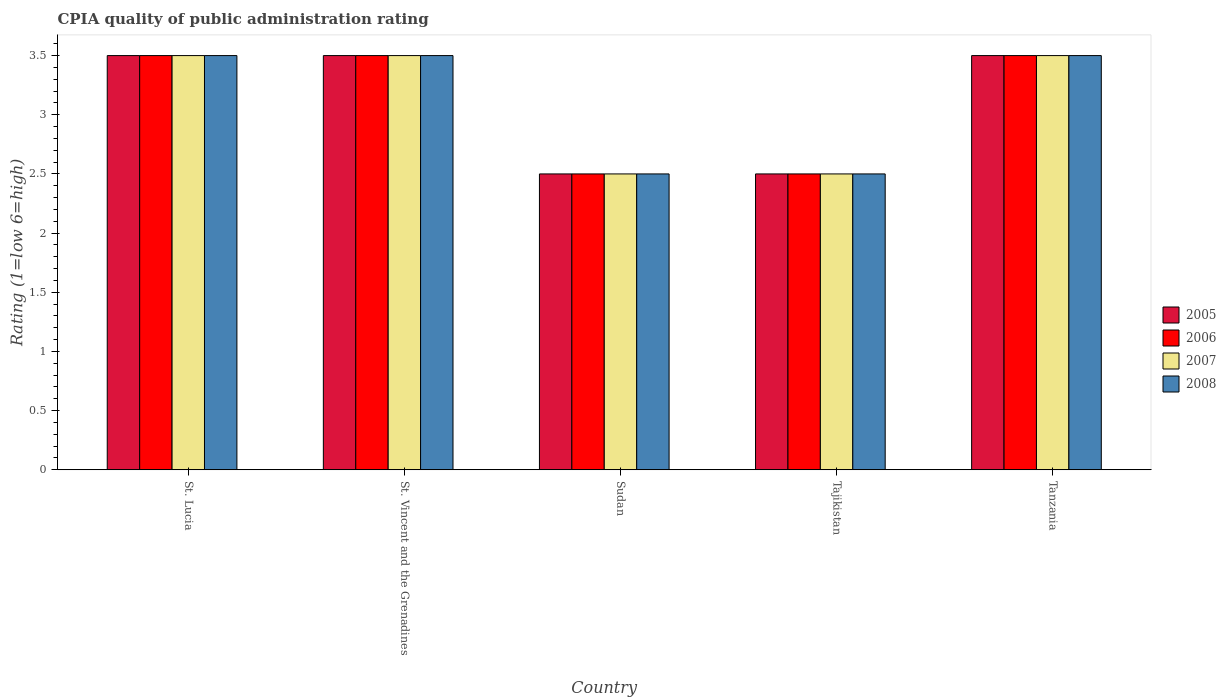How many different coloured bars are there?
Ensure brevity in your answer.  4. How many groups of bars are there?
Make the answer very short. 5. Are the number of bars on each tick of the X-axis equal?
Ensure brevity in your answer.  Yes. How many bars are there on the 5th tick from the right?
Keep it short and to the point. 4. What is the label of the 3rd group of bars from the left?
Give a very brief answer. Sudan. Across all countries, what is the maximum CPIA rating in 2008?
Make the answer very short. 3.5. In which country was the CPIA rating in 2006 maximum?
Provide a succinct answer. St. Lucia. In which country was the CPIA rating in 2008 minimum?
Your response must be concise. Sudan. What is the average CPIA rating in 2005 per country?
Offer a very short reply. 3.1. What is the difference between the CPIA rating of/in 2006 and CPIA rating of/in 2005 in St. Vincent and the Grenadines?
Keep it short and to the point. 0. In how many countries, is the CPIA rating in 2006 greater than 2.2?
Your answer should be compact. 5. Is the difference between the CPIA rating in 2006 in St. Vincent and the Grenadines and Sudan greater than the difference between the CPIA rating in 2005 in St. Vincent and the Grenadines and Sudan?
Make the answer very short. No. In how many countries, is the CPIA rating in 2005 greater than the average CPIA rating in 2005 taken over all countries?
Offer a terse response. 3. Is the sum of the CPIA rating in 2005 in St. Vincent and the Grenadines and Tanzania greater than the maximum CPIA rating in 2006 across all countries?
Your response must be concise. Yes. Is it the case that in every country, the sum of the CPIA rating in 2007 and CPIA rating in 2006 is greater than the sum of CPIA rating in 2008 and CPIA rating in 2005?
Provide a short and direct response. No. What does the 1st bar from the right in Tajikistan represents?
Offer a very short reply. 2008. Are the values on the major ticks of Y-axis written in scientific E-notation?
Ensure brevity in your answer.  No. Does the graph contain grids?
Give a very brief answer. No. Where does the legend appear in the graph?
Ensure brevity in your answer.  Center right. How many legend labels are there?
Your response must be concise. 4. How are the legend labels stacked?
Ensure brevity in your answer.  Vertical. What is the title of the graph?
Ensure brevity in your answer.  CPIA quality of public administration rating. Does "1968" appear as one of the legend labels in the graph?
Your answer should be very brief. No. What is the label or title of the X-axis?
Offer a terse response. Country. What is the Rating (1=low 6=high) of 2005 in St. Lucia?
Your response must be concise. 3.5. What is the Rating (1=low 6=high) in 2007 in St. Lucia?
Give a very brief answer. 3.5. What is the Rating (1=low 6=high) of 2007 in St. Vincent and the Grenadines?
Your answer should be very brief. 3.5. What is the Rating (1=low 6=high) of 2008 in St. Vincent and the Grenadines?
Provide a short and direct response. 3.5. What is the Rating (1=low 6=high) of 2005 in Sudan?
Keep it short and to the point. 2.5. What is the Rating (1=low 6=high) in 2007 in Sudan?
Your answer should be very brief. 2.5. What is the Rating (1=low 6=high) of 2005 in Tajikistan?
Your answer should be compact. 2.5. What is the Rating (1=low 6=high) of 2008 in Tajikistan?
Make the answer very short. 2.5. What is the Rating (1=low 6=high) of 2006 in Tanzania?
Ensure brevity in your answer.  3.5. Across all countries, what is the maximum Rating (1=low 6=high) of 2006?
Provide a short and direct response. 3.5. Across all countries, what is the minimum Rating (1=low 6=high) of 2005?
Keep it short and to the point. 2.5. Across all countries, what is the minimum Rating (1=low 6=high) of 2007?
Provide a short and direct response. 2.5. Across all countries, what is the minimum Rating (1=low 6=high) of 2008?
Make the answer very short. 2.5. What is the total Rating (1=low 6=high) in 2006 in the graph?
Give a very brief answer. 15.5. What is the difference between the Rating (1=low 6=high) of 2005 in St. Lucia and that in St. Vincent and the Grenadines?
Give a very brief answer. 0. What is the difference between the Rating (1=low 6=high) in 2006 in St. Lucia and that in St. Vincent and the Grenadines?
Offer a terse response. 0. What is the difference between the Rating (1=low 6=high) of 2006 in St. Lucia and that in Sudan?
Keep it short and to the point. 1. What is the difference between the Rating (1=low 6=high) of 2007 in St. Lucia and that in Sudan?
Offer a very short reply. 1. What is the difference between the Rating (1=low 6=high) of 2008 in St. Lucia and that in Sudan?
Your response must be concise. 1. What is the difference between the Rating (1=low 6=high) in 2006 in St. Lucia and that in Tajikistan?
Offer a very short reply. 1. What is the difference between the Rating (1=low 6=high) in 2008 in St. Lucia and that in Tajikistan?
Provide a succinct answer. 1. What is the difference between the Rating (1=low 6=high) of 2005 in St. Lucia and that in Tanzania?
Provide a succinct answer. 0. What is the difference between the Rating (1=low 6=high) of 2006 in St. Lucia and that in Tanzania?
Provide a short and direct response. 0. What is the difference between the Rating (1=low 6=high) of 2007 in St. Lucia and that in Tanzania?
Offer a very short reply. 0. What is the difference between the Rating (1=low 6=high) in 2005 in St. Vincent and the Grenadines and that in Sudan?
Give a very brief answer. 1. What is the difference between the Rating (1=low 6=high) of 2006 in St. Vincent and the Grenadines and that in Sudan?
Give a very brief answer. 1. What is the difference between the Rating (1=low 6=high) of 2007 in St. Vincent and the Grenadines and that in Sudan?
Offer a very short reply. 1. What is the difference between the Rating (1=low 6=high) of 2006 in St. Vincent and the Grenadines and that in Tajikistan?
Your answer should be compact. 1. What is the difference between the Rating (1=low 6=high) of 2007 in St. Vincent and the Grenadines and that in Tajikistan?
Your response must be concise. 1. What is the difference between the Rating (1=low 6=high) in 2008 in St. Vincent and the Grenadines and that in Tajikistan?
Your answer should be compact. 1. What is the difference between the Rating (1=low 6=high) of 2005 in St. Vincent and the Grenadines and that in Tanzania?
Your answer should be compact. 0. What is the difference between the Rating (1=low 6=high) in 2007 in St. Vincent and the Grenadines and that in Tanzania?
Your answer should be very brief. 0. What is the difference between the Rating (1=low 6=high) in 2005 in Sudan and that in Tajikistan?
Your response must be concise. 0. What is the difference between the Rating (1=low 6=high) in 2005 in Sudan and that in Tanzania?
Your response must be concise. -1. What is the difference between the Rating (1=low 6=high) in 2007 in Sudan and that in Tanzania?
Your answer should be very brief. -1. What is the difference between the Rating (1=low 6=high) of 2008 in Sudan and that in Tanzania?
Provide a succinct answer. -1. What is the difference between the Rating (1=low 6=high) in 2006 in Tajikistan and that in Tanzania?
Make the answer very short. -1. What is the difference between the Rating (1=low 6=high) in 2007 in Tajikistan and that in Tanzania?
Make the answer very short. -1. What is the difference between the Rating (1=low 6=high) of 2008 in Tajikistan and that in Tanzania?
Make the answer very short. -1. What is the difference between the Rating (1=low 6=high) in 2005 in St. Lucia and the Rating (1=low 6=high) in 2006 in St. Vincent and the Grenadines?
Give a very brief answer. 0. What is the difference between the Rating (1=low 6=high) of 2005 in St. Lucia and the Rating (1=low 6=high) of 2008 in St. Vincent and the Grenadines?
Give a very brief answer. 0. What is the difference between the Rating (1=low 6=high) in 2006 in St. Lucia and the Rating (1=low 6=high) in 2008 in St. Vincent and the Grenadines?
Your answer should be compact. 0. What is the difference between the Rating (1=low 6=high) in 2005 in St. Lucia and the Rating (1=low 6=high) in 2006 in Sudan?
Provide a short and direct response. 1. What is the difference between the Rating (1=low 6=high) of 2005 in St. Lucia and the Rating (1=low 6=high) of 2007 in Sudan?
Ensure brevity in your answer.  1. What is the difference between the Rating (1=low 6=high) in 2005 in St. Lucia and the Rating (1=low 6=high) in 2008 in Sudan?
Your response must be concise. 1. What is the difference between the Rating (1=low 6=high) of 2006 in St. Lucia and the Rating (1=low 6=high) of 2007 in Sudan?
Provide a succinct answer. 1. What is the difference between the Rating (1=low 6=high) of 2006 in St. Lucia and the Rating (1=low 6=high) of 2008 in Sudan?
Offer a very short reply. 1. What is the difference between the Rating (1=low 6=high) of 2007 in St. Lucia and the Rating (1=low 6=high) of 2008 in Sudan?
Make the answer very short. 1. What is the difference between the Rating (1=low 6=high) of 2005 in St. Lucia and the Rating (1=low 6=high) of 2006 in Tajikistan?
Ensure brevity in your answer.  1. What is the difference between the Rating (1=low 6=high) in 2005 in St. Lucia and the Rating (1=low 6=high) in 2007 in Tajikistan?
Offer a very short reply. 1. What is the difference between the Rating (1=low 6=high) of 2006 in St. Lucia and the Rating (1=low 6=high) of 2007 in Tajikistan?
Provide a short and direct response. 1. What is the difference between the Rating (1=low 6=high) in 2006 in St. Lucia and the Rating (1=low 6=high) in 2008 in Tajikistan?
Give a very brief answer. 1. What is the difference between the Rating (1=low 6=high) in 2005 in St. Lucia and the Rating (1=low 6=high) in 2007 in Tanzania?
Your response must be concise. 0. What is the difference between the Rating (1=low 6=high) in 2006 in St. Lucia and the Rating (1=low 6=high) in 2007 in Tanzania?
Give a very brief answer. 0. What is the difference between the Rating (1=low 6=high) of 2005 in St. Vincent and the Grenadines and the Rating (1=low 6=high) of 2007 in Sudan?
Keep it short and to the point. 1. What is the difference between the Rating (1=low 6=high) in 2006 in St. Vincent and the Grenadines and the Rating (1=low 6=high) in 2008 in Sudan?
Provide a short and direct response. 1. What is the difference between the Rating (1=low 6=high) in 2005 in St. Vincent and the Grenadines and the Rating (1=low 6=high) in 2007 in Tajikistan?
Ensure brevity in your answer.  1. What is the difference between the Rating (1=low 6=high) of 2006 in St. Vincent and the Grenadines and the Rating (1=low 6=high) of 2007 in Tajikistan?
Ensure brevity in your answer.  1. What is the difference between the Rating (1=low 6=high) of 2006 in St. Vincent and the Grenadines and the Rating (1=low 6=high) of 2008 in Tajikistan?
Ensure brevity in your answer.  1. What is the difference between the Rating (1=low 6=high) of 2007 in St. Vincent and the Grenadines and the Rating (1=low 6=high) of 2008 in Tajikistan?
Keep it short and to the point. 1. What is the difference between the Rating (1=low 6=high) in 2005 in St. Vincent and the Grenadines and the Rating (1=low 6=high) in 2006 in Tanzania?
Offer a very short reply. 0. What is the difference between the Rating (1=low 6=high) in 2005 in St. Vincent and the Grenadines and the Rating (1=low 6=high) in 2008 in Tanzania?
Keep it short and to the point. 0. What is the difference between the Rating (1=low 6=high) of 2006 in St. Vincent and the Grenadines and the Rating (1=low 6=high) of 2007 in Tanzania?
Your answer should be very brief. 0. What is the difference between the Rating (1=low 6=high) in 2005 in Sudan and the Rating (1=low 6=high) in 2006 in Tajikistan?
Keep it short and to the point. 0. What is the difference between the Rating (1=low 6=high) in 2005 in Sudan and the Rating (1=low 6=high) in 2008 in Tajikistan?
Provide a succinct answer. 0. What is the difference between the Rating (1=low 6=high) in 2006 in Sudan and the Rating (1=low 6=high) in 2007 in Tajikistan?
Your answer should be compact. 0. What is the difference between the Rating (1=low 6=high) of 2005 in Sudan and the Rating (1=low 6=high) of 2007 in Tanzania?
Give a very brief answer. -1. What is the difference between the Rating (1=low 6=high) in 2005 in Sudan and the Rating (1=low 6=high) in 2008 in Tanzania?
Make the answer very short. -1. What is the difference between the Rating (1=low 6=high) of 2006 in Sudan and the Rating (1=low 6=high) of 2008 in Tanzania?
Your answer should be compact. -1. What is the difference between the Rating (1=low 6=high) of 2007 in Sudan and the Rating (1=low 6=high) of 2008 in Tanzania?
Ensure brevity in your answer.  -1. What is the difference between the Rating (1=low 6=high) in 2005 in Tajikistan and the Rating (1=low 6=high) in 2006 in Tanzania?
Offer a very short reply. -1. What is the difference between the Rating (1=low 6=high) of 2005 in Tajikistan and the Rating (1=low 6=high) of 2007 in Tanzania?
Give a very brief answer. -1. What is the difference between the Rating (1=low 6=high) in 2005 in Tajikistan and the Rating (1=low 6=high) in 2008 in Tanzania?
Ensure brevity in your answer.  -1. What is the average Rating (1=low 6=high) of 2008 per country?
Provide a succinct answer. 3.1. What is the difference between the Rating (1=low 6=high) of 2005 and Rating (1=low 6=high) of 2007 in St. Lucia?
Your answer should be very brief. 0. What is the difference between the Rating (1=low 6=high) in 2006 and Rating (1=low 6=high) in 2008 in St. Lucia?
Give a very brief answer. 0. What is the difference between the Rating (1=low 6=high) of 2006 and Rating (1=low 6=high) of 2007 in St. Vincent and the Grenadines?
Provide a short and direct response. 0. What is the difference between the Rating (1=low 6=high) in 2006 and Rating (1=low 6=high) in 2008 in St. Vincent and the Grenadines?
Offer a terse response. 0. What is the difference between the Rating (1=low 6=high) of 2007 and Rating (1=low 6=high) of 2008 in St. Vincent and the Grenadines?
Give a very brief answer. 0. What is the difference between the Rating (1=low 6=high) of 2005 and Rating (1=low 6=high) of 2006 in Sudan?
Keep it short and to the point. 0. What is the difference between the Rating (1=low 6=high) of 2005 and Rating (1=low 6=high) of 2008 in Sudan?
Your answer should be compact. 0. What is the difference between the Rating (1=low 6=high) in 2005 and Rating (1=low 6=high) in 2006 in Tajikistan?
Provide a succinct answer. 0. What is the difference between the Rating (1=low 6=high) of 2005 and Rating (1=low 6=high) of 2008 in Tajikistan?
Give a very brief answer. 0. What is the difference between the Rating (1=low 6=high) in 2006 and Rating (1=low 6=high) in 2008 in Tajikistan?
Offer a very short reply. 0. What is the difference between the Rating (1=low 6=high) in 2007 and Rating (1=low 6=high) in 2008 in Tajikistan?
Ensure brevity in your answer.  0. What is the difference between the Rating (1=low 6=high) of 2005 and Rating (1=low 6=high) of 2007 in Tanzania?
Offer a terse response. 0. What is the difference between the Rating (1=low 6=high) in 2006 and Rating (1=low 6=high) in 2008 in Tanzania?
Your answer should be very brief. 0. What is the ratio of the Rating (1=low 6=high) in 2006 in St. Lucia to that in St. Vincent and the Grenadines?
Make the answer very short. 1. What is the ratio of the Rating (1=low 6=high) of 2007 in St. Lucia to that in St. Vincent and the Grenadines?
Provide a short and direct response. 1. What is the ratio of the Rating (1=low 6=high) of 2005 in St. Lucia to that in Sudan?
Make the answer very short. 1.4. What is the ratio of the Rating (1=low 6=high) of 2007 in St. Lucia to that in Sudan?
Make the answer very short. 1.4. What is the ratio of the Rating (1=low 6=high) of 2005 in St. Lucia to that in Tajikistan?
Offer a very short reply. 1.4. What is the ratio of the Rating (1=low 6=high) in 2006 in St. Lucia to that in Tajikistan?
Provide a short and direct response. 1.4. What is the ratio of the Rating (1=low 6=high) of 2007 in St. Lucia to that in Tajikistan?
Give a very brief answer. 1.4. What is the ratio of the Rating (1=low 6=high) of 2005 in St. Lucia to that in Tanzania?
Provide a short and direct response. 1. What is the ratio of the Rating (1=low 6=high) of 2006 in St. Lucia to that in Tanzania?
Your answer should be very brief. 1. What is the ratio of the Rating (1=low 6=high) in 2007 in St. Lucia to that in Tanzania?
Offer a very short reply. 1. What is the ratio of the Rating (1=low 6=high) of 2005 in St. Vincent and the Grenadines to that in Sudan?
Your response must be concise. 1.4. What is the ratio of the Rating (1=low 6=high) in 2007 in St. Vincent and the Grenadines to that in Tajikistan?
Give a very brief answer. 1.4. What is the ratio of the Rating (1=low 6=high) in 2005 in St. Vincent and the Grenadines to that in Tanzania?
Your response must be concise. 1. What is the ratio of the Rating (1=low 6=high) in 2006 in St. Vincent and the Grenadines to that in Tanzania?
Ensure brevity in your answer.  1. What is the ratio of the Rating (1=low 6=high) in 2007 in St. Vincent and the Grenadines to that in Tanzania?
Your answer should be compact. 1. What is the ratio of the Rating (1=low 6=high) of 2006 in Sudan to that in Tajikistan?
Keep it short and to the point. 1. What is the ratio of the Rating (1=low 6=high) in 2008 in Sudan to that in Tajikistan?
Offer a very short reply. 1. What is the ratio of the Rating (1=low 6=high) of 2006 in Sudan to that in Tanzania?
Your response must be concise. 0.71. What is the ratio of the Rating (1=low 6=high) of 2005 in Tajikistan to that in Tanzania?
Your answer should be compact. 0.71. What is the ratio of the Rating (1=low 6=high) in 2007 in Tajikistan to that in Tanzania?
Your answer should be very brief. 0.71. What is the ratio of the Rating (1=low 6=high) in 2008 in Tajikistan to that in Tanzania?
Your answer should be very brief. 0.71. What is the difference between the highest and the second highest Rating (1=low 6=high) in 2007?
Provide a short and direct response. 0. What is the difference between the highest and the lowest Rating (1=low 6=high) in 2006?
Ensure brevity in your answer.  1. What is the difference between the highest and the lowest Rating (1=low 6=high) in 2007?
Offer a terse response. 1. What is the difference between the highest and the lowest Rating (1=low 6=high) of 2008?
Give a very brief answer. 1. 